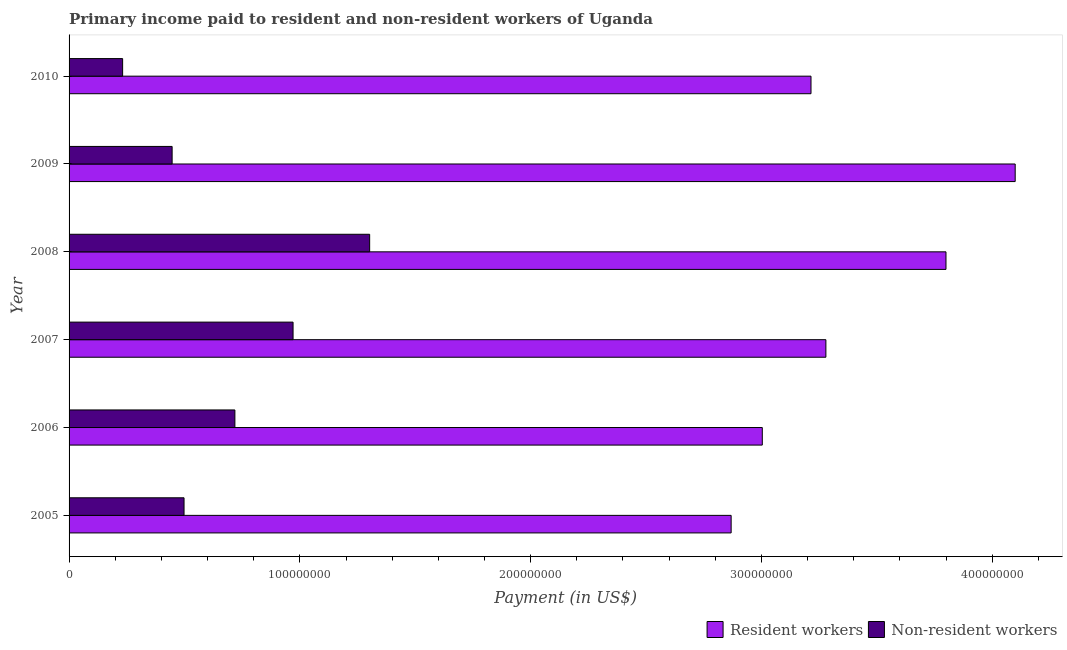How many different coloured bars are there?
Offer a terse response. 2. How many groups of bars are there?
Your answer should be very brief. 6. Are the number of bars per tick equal to the number of legend labels?
Offer a very short reply. Yes. How many bars are there on the 5th tick from the top?
Provide a short and direct response. 2. How many bars are there on the 3rd tick from the bottom?
Make the answer very short. 2. What is the label of the 5th group of bars from the top?
Give a very brief answer. 2006. In how many cases, is the number of bars for a given year not equal to the number of legend labels?
Provide a succinct answer. 0. What is the payment made to resident workers in 2009?
Your answer should be compact. 4.10e+08. Across all years, what is the maximum payment made to resident workers?
Keep it short and to the point. 4.10e+08. Across all years, what is the minimum payment made to non-resident workers?
Keep it short and to the point. 2.32e+07. In which year was the payment made to non-resident workers maximum?
Offer a very short reply. 2008. In which year was the payment made to non-resident workers minimum?
Your answer should be compact. 2010. What is the total payment made to resident workers in the graph?
Make the answer very short. 2.03e+09. What is the difference between the payment made to non-resident workers in 2005 and that in 2006?
Provide a short and direct response. -2.20e+07. What is the difference between the payment made to resident workers in 2006 and the payment made to non-resident workers in 2010?
Give a very brief answer. 2.77e+08. What is the average payment made to non-resident workers per year?
Give a very brief answer. 6.95e+07. In the year 2007, what is the difference between the payment made to resident workers and payment made to non-resident workers?
Your response must be concise. 2.31e+08. What is the ratio of the payment made to resident workers in 2005 to that in 2008?
Ensure brevity in your answer.  0.76. What is the difference between the highest and the second highest payment made to non-resident workers?
Provide a succinct answer. 3.32e+07. What is the difference between the highest and the lowest payment made to non-resident workers?
Your answer should be very brief. 1.07e+08. In how many years, is the payment made to non-resident workers greater than the average payment made to non-resident workers taken over all years?
Provide a short and direct response. 3. Is the sum of the payment made to non-resident workers in 2005 and 2007 greater than the maximum payment made to resident workers across all years?
Keep it short and to the point. No. What does the 2nd bar from the top in 2006 represents?
Offer a terse response. Resident workers. What does the 2nd bar from the bottom in 2008 represents?
Provide a short and direct response. Non-resident workers. How many bars are there?
Ensure brevity in your answer.  12. Are all the bars in the graph horizontal?
Offer a terse response. Yes. How many years are there in the graph?
Provide a succinct answer. 6. Are the values on the major ticks of X-axis written in scientific E-notation?
Provide a succinct answer. No. What is the title of the graph?
Offer a very short reply. Primary income paid to resident and non-resident workers of Uganda. Does "Chemicals" appear as one of the legend labels in the graph?
Your answer should be very brief. No. What is the label or title of the X-axis?
Provide a short and direct response. Payment (in US$). What is the label or title of the Y-axis?
Offer a very short reply. Year. What is the Payment (in US$) of Resident workers in 2005?
Offer a very short reply. 2.87e+08. What is the Payment (in US$) of Non-resident workers in 2005?
Provide a succinct answer. 4.98e+07. What is the Payment (in US$) in Resident workers in 2006?
Offer a very short reply. 3.00e+08. What is the Payment (in US$) in Non-resident workers in 2006?
Your answer should be very brief. 7.19e+07. What is the Payment (in US$) of Resident workers in 2007?
Make the answer very short. 3.28e+08. What is the Payment (in US$) of Non-resident workers in 2007?
Offer a very short reply. 9.71e+07. What is the Payment (in US$) of Resident workers in 2008?
Your answer should be compact. 3.80e+08. What is the Payment (in US$) in Non-resident workers in 2008?
Ensure brevity in your answer.  1.30e+08. What is the Payment (in US$) of Resident workers in 2009?
Provide a succinct answer. 4.10e+08. What is the Payment (in US$) of Non-resident workers in 2009?
Your answer should be compact. 4.47e+07. What is the Payment (in US$) of Resident workers in 2010?
Ensure brevity in your answer.  3.21e+08. What is the Payment (in US$) of Non-resident workers in 2010?
Offer a very short reply. 2.32e+07. Across all years, what is the maximum Payment (in US$) in Resident workers?
Provide a short and direct response. 4.10e+08. Across all years, what is the maximum Payment (in US$) of Non-resident workers?
Provide a succinct answer. 1.30e+08. Across all years, what is the minimum Payment (in US$) in Resident workers?
Ensure brevity in your answer.  2.87e+08. Across all years, what is the minimum Payment (in US$) of Non-resident workers?
Make the answer very short. 2.32e+07. What is the total Payment (in US$) in Resident workers in the graph?
Provide a short and direct response. 2.03e+09. What is the total Payment (in US$) of Non-resident workers in the graph?
Give a very brief answer. 4.17e+08. What is the difference between the Payment (in US$) in Resident workers in 2005 and that in 2006?
Give a very brief answer. -1.35e+07. What is the difference between the Payment (in US$) of Non-resident workers in 2005 and that in 2006?
Give a very brief answer. -2.20e+07. What is the difference between the Payment (in US$) in Resident workers in 2005 and that in 2007?
Your response must be concise. -4.11e+07. What is the difference between the Payment (in US$) of Non-resident workers in 2005 and that in 2007?
Your answer should be compact. -4.72e+07. What is the difference between the Payment (in US$) in Resident workers in 2005 and that in 2008?
Provide a short and direct response. -9.31e+07. What is the difference between the Payment (in US$) of Non-resident workers in 2005 and that in 2008?
Offer a terse response. -8.04e+07. What is the difference between the Payment (in US$) in Resident workers in 2005 and that in 2009?
Give a very brief answer. -1.23e+08. What is the difference between the Payment (in US$) in Non-resident workers in 2005 and that in 2009?
Offer a very short reply. 5.16e+06. What is the difference between the Payment (in US$) of Resident workers in 2005 and that in 2010?
Keep it short and to the point. -3.46e+07. What is the difference between the Payment (in US$) in Non-resident workers in 2005 and that in 2010?
Keep it short and to the point. 2.66e+07. What is the difference between the Payment (in US$) in Resident workers in 2006 and that in 2007?
Your answer should be compact. -2.76e+07. What is the difference between the Payment (in US$) of Non-resident workers in 2006 and that in 2007?
Make the answer very short. -2.52e+07. What is the difference between the Payment (in US$) of Resident workers in 2006 and that in 2008?
Make the answer very short. -7.96e+07. What is the difference between the Payment (in US$) in Non-resident workers in 2006 and that in 2008?
Keep it short and to the point. -5.84e+07. What is the difference between the Payment (in US$) of Resident workers in 2006 and that in 2009?
Keep it short and to the point. -1.10e+08. What is the difference between the Payment (in US$) in Non-resident workers in 2006 and that in 2009?
Offer a very short reply. 2.72e+07. What is the difference between the Payment (in US$) of Resident workers in 2006 and that in 2010?
Offer a very short reply. -2.11e+07. What is the difference between the Payment (in US$) in Non-resident workers in 2006 and that in 2010?
Keep it short and to the point. 4.86e+07. What is the difference between the Payment (in US$) in Resident workers in 2007 and that in 2008?
Make the answer very short. -5.20e+07. What is the difference between the Payment (in US$) in Non-resident workers in 2007 and that in 2008?
Ensure brevity in your answer.  -3.32e+07. What is the difference between the Payment (in US$) in Resident workers in 2007 and that in 2009?
Keep it short and to the point. -8.20e+07. What is the difference between the Payment (in US$) in Non-resident workers in 2007 and that in 2009?
Provide a short and direct response. 5.24e+07. What is the difference between the Payment (in US$) in Resident workers in 2007 and that in 2010?
Provide a short and direct response. 6.45e+06. What is the difference between the Payment (in US$) of Non-resident workers in 2007 and that in 2010?
Keep it short and to the point. 7.39e+07. What is the difference between the Payment (in US$) of Resident workers in 2008 and that in 2009?
Give a very brief answer. -3.00e+07. What is the difference between the Payment (in US$) in Non-resident workers in 2008 and that in 2009?
Make the answer very short. 8.56e+07. What is the difference between the Payment (in US$) of Resident workers in 2008 and that in 2010?
Ensure brevity in your answer.  5.85e+07. What is the difference between the Payment (in US$) of Non-resident workers in 2008 and that in 2010?
Make the answer very short. 1.07e+08. What is the difference between the Payment (in US$) of Resident workers in 2009 and that in 2010?
Your answer should be compact. 8.85e+07. What is the difference between the Payment (in US$) in Non-resident workers in 2009 and that in 2010?
Ensure brevity in your answer.  2.15e+07. What is the difference between the Payment (in US$) in Resident workers in 2005 and the Payment (in US$) in Non-resident workers in 2006?
Offer a very short reply. 2.15e+08. What is the difference between the Payment (in US$) of Resident workers in 2005 and the Payment (in US$) of Non-resident workers in 2007?
Offer a terse response. 1.90e+08. What is the difference between the Payment (in US$) of Resident workers in 2005 and the Payment (in US$) of Non-resident workers in 2008?
Provide a succinct answer. 1.57e+08. What is the difference between the Payment (in US$) of Resident workers in 2005 and the Payment (in US$) of Non-resident workers in 2009?
Your answer should be very brief. 2.42e+08. What is the difference between the Payment (in US$) in Resident workers in 2005 and the Payment (in US$) in Non-resident workers in 2010?
Your response must be concise. 2.64e+08. What is the difference between the Payment (in US$) of Resident workers in 2006 and the Payment (in US$) of Non-resident workers in 2007?
Ensure brevity in your answer.  2.03e+08. What is the difference between the Payment (in US$) of Resident workers in 2006 and the Payment (in US$) of Non-resident workers in 2008?
Your answer should be compact. 1.70e+08. What is the difference between the Payment (in US$) of Resident workers in 2006 and the Payment (in US$) of Non-resident workers in 2009?
Make the answer very short. 2.56e+08. What is the difference between the Payment (in US$) of Resident workers in 2006 and the Payment (in US$) of Non-resident workers in 2010?
Ensure brevity in your answer.  2.77e+08. What is the difference between the Payment (in US$) of Resident workers in 2007 and the Payment (in US$) of Non-resident workers in 2008?
Your response must be concise. 1.98e+08. What is the difference between the Payment (in US$) of Resident workers in 2007 and the Payment (in US$) of Non-resident workers in 2009?
Keep it short and to the point. 2.83e+08. What is the difference between the Payment (in US$) of Resident workers in 2007 and the Payment (in US$) of Non-resident workers in 2010?
Offer a terse response. 3.05e+08. What is the difference between the Payment (in US$) in Resident workers in 2008 and the Payment (in US$) in Non-resident workers in 2009?
Provide a succinct answer. 3.35e+08. What is the difference between the Payment (in US$) in Resident workers in 2008 and the Payment (in US$) in Non-resident workers in 2010?
Provide a succinct answer. 3.57e+08. What is the difference between the Payment (in US$) of Resident workers in 2009 and the Payment (in US$) of Non-resident workers in 2010?
Keep it short and to the point. 3.87e+08. What is the average Payment (in US$) in Resident workers per year?
Make the answer very short. 3.38e+08. What is the average Payment (in US$) of Non-resident workers per year?
Your response must be concise. 6.95e+07. In the year 2005, what is the difference between the Payment (in US$) of Resident workers and Payment (in US$) of Non-resident workers?
Provide a succinct answer. 2.37e+08. In the year 2006, what is the difference between the Payment (in US$) of Resident workers and Payment (in US$) of Non-resident workers?
Offer a very short reply. 2.29e+08. In the year 2007, what is the difference between the Payment (in US$) in Resident workers and Payment (in US$) in Non-resident workers?
Keep it short and to the point. 2.31e+08. In the year 2008, what is the difference between the Payment (in US$) in Resident workers and Payment (in US$) in Non-resident workers?
Provide a short and direct response. 2.50e+08. In the year 2009, what is the difference between the Payment (in US$) of Resident workers and Payment (in US$) of Non-resident workers?
Make the answer very short. 3.65e+08. In the year 2010, what is the difference between the Payment (in US$) in Resident workers and Payment (in US$) in Non-resident workers?
Your response must be concise. 2.98e+08. What is the ratio of the Payment (in US$) of Resident workers in 2005 to that in 2006?
Offer a very short reply. 0.96. What is the ratio of the Payment (in US$) of Non-resident workers in 2005 to that in 2006?
Offer a very short reply. 0.69. What is the ratio of the Payment (in US$) of Resident workers in 2005 to that in 2007?
Offer a terse response. 0.87. What is the ratio of the Payment (in US$) in Non-resident workers in 2005 to that in 2007?
Provide a succinct answer. 0.51. What is the ratio of the Payment (in US$) of Resident workers in 2005 to that in 2008?
Offer a terse response. 0.76. What is the ratio of the Payment (in US$) in Non-resident workers in 2005 to that in 2008?
Your answer should be compact. 0.38. What is the ratio of the Payment (in US$) of Resident workers in 2005 to that in 2009?
Provide a succinct answer. 0.7. What is the ratio of the Payment (in US$) of Non-resident workers in 2005 to that in 2009?
Offer a very short reply. 1.12. What is the ratio of the Payment (in US$) of Resident workers in 2005 to that in 2010?
Your response must be concise. 0.89. What is the ratio of the Payment (in US$) of Non-resident workers in 2005 to that in 2010?
Provide a short and direct response. 2.15. What is the ratio of the Payment (in US$) in Resident workers in 2006 to that in 2007?
Your response must be concise. 0.92. What is the ratio of the Payment (in US$) in Non-resident workers in 2006 to that in 2007?
Give a very brief answer. 0.74. What is the ratio of the Payment (in US$) in Resident workers in 2006 to that in 2008?
Offer a terse response. 0.79. What is the ratio of the Payment (in US$) of Non-resident workers in 2006 to that in 2008?
Ensure brevity in your answer.  0.55. What is the ratio of the Payment (in US$) of Resident workers in 2006 to that in 2009?
Ensure brevity in your answer.  0.73. What is the ratio of the Payment (in US$) in Non-resident workers in 2006 to that in 2009?
Provide a succinct answer. 1.61. What is the ratio of the Payment (in US$) in Resident workers in 2006 to that in 2010?
Your answer should be compact. 0.93. What is the ratio of the Payment (in US$) of Non-resident workers in 2006 to that in 2010?
Provide a succinct answer. 3.1. What is the ratio of the Payment (in US$) of Resident workers in 2007 to that in 2008?
Your response must be concise. 0.86. What is the ratio of the Payment (in US$) in Non-resident workers in 2007 to that in 2008?
Offer a very short reply. 0.75. What is the ratio of the Payment (in US$) in Resident workers in 2007 to that in 2009?
Your response must be concise. 0.8. What is the ratio of the Payment (in US$) of Non-resident workers in 2007 to that in 2009?
Your answer should be very brief. 2.17. What is the ratio of the Payment (in US$) of Resident workers in 2007 to that in 2010?
Your answer should be compact. 1.02. What is the ratio of the Payment (in US$) of Non-resident workers in 2007 to that in 2010?
Offer a very short reply. 4.18. What is the ratio of the Payment (in US$) of Resident workers in 2008 to that in 2009?
Provide a succinct answer. 0.93. What is the ratio of the Payment (in US$) of Non-resident workers in 2008 to that in 2009?
Offer a terse response. 2.92. What is the ratio of the Payment (in US$) of Resident workers in 2008 to that in 2010?
Offer a very short reply. 1.18. What is the ratio of the Payment (in US$) in Non-resident workers in 2008 to that in 2010?
Provide a short and direct response. 5.61. What is the ratio of the Payment (in US$) in Resident workers in 2009 to that in 2010?
Offer a terse response. 1.28. What is the ratio of the Payment (in US$) of Non-resident workers in 2009 to that in 2010?
Offer a very short reply. 1.92. What is the difference between the highest and the second highest Payment (in US$) of Resident workers?
Your response must be concise. 3.00e+07. What is the difference between the highest and the second highest Payment (in US$) in Non-resident workers?
Provide a short and direct response. 3.32e+07. What is the difference between the highest and the lowest Payment (in US$) of Resident workers?
Make the answer very short. 1.23e+08. What is the difference between the highest and the lowest Payment (in US$) of Non-resident workers?
Give a very brief answer. 1.07e+08. 